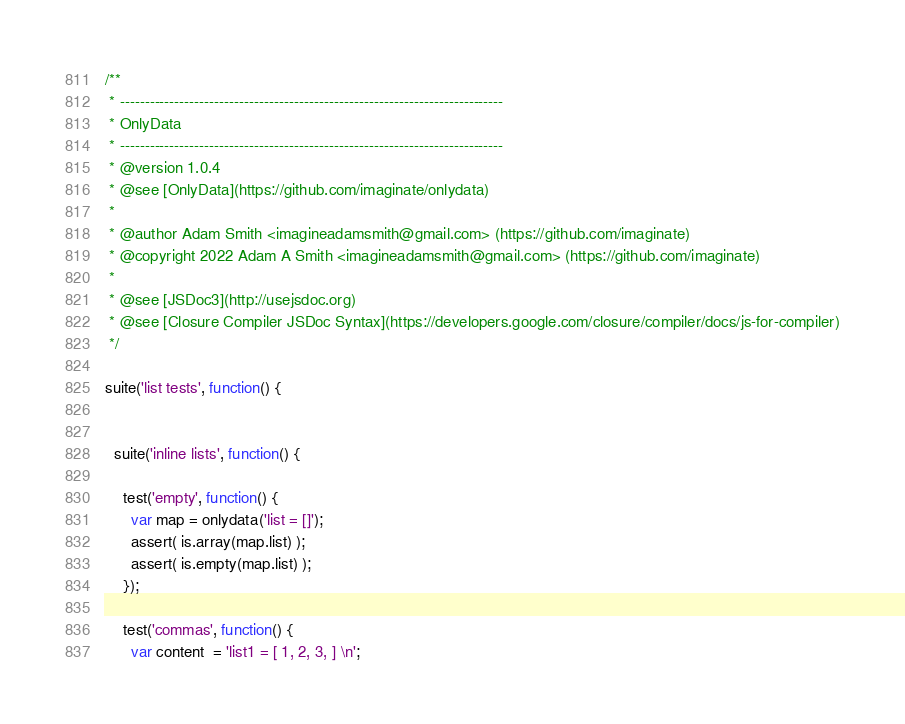<code> <loc_0><loc_0><loc_500><loc_500><_JavaScript_>/**
 * -----------------------------------------------------------------------------
 * OnlyData
 * -----------------------------------------------------------------------------
 * @version 1.0.4
 * @see [OnlyData](https://github.com/imaginate/onlydata)
 *
 * @author Adam Smith <imagineadamsmith@gmail.com> (https://github.com/imaginate)
 * @copyright 2022 Adam A Smith <imagineadamsmith@gmail.com> (https://github.com/imaginate)
 *
 * @see [JSDoc3](http://usejsdoc.org)
 * @see [Closure Compiler JSDoc Syntax](https://developers.google.com/closure/compiler/docs/js-for-compiler)
 */

suite('list tests', function() {


  suite('inline lists', function() {

    test('empty', function() {
      var map = onlydata('list = []');
      assert( is.array(map.list) );
      assert( is.empty(map.list) );
    });

    test('commas', function() {
      var content  = 'list1 = [ 1, 2, 3, ] \n';</code> 